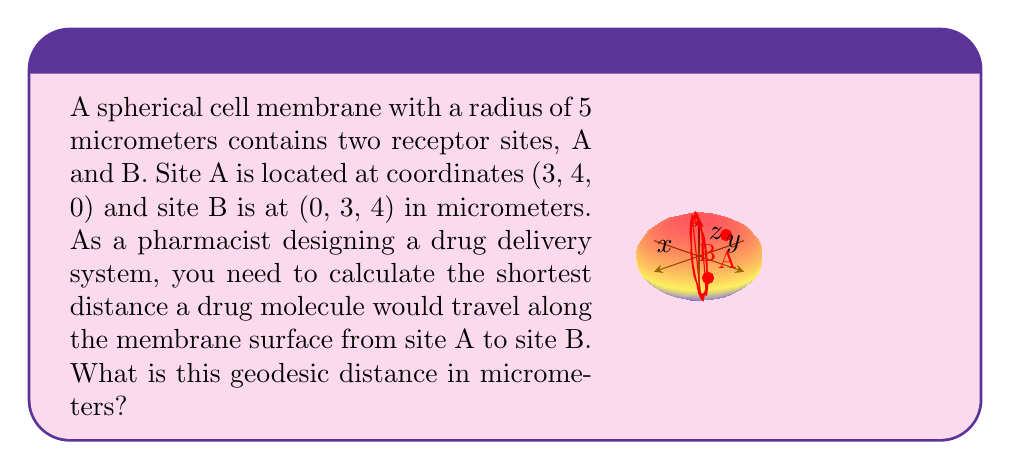Help me with this question. To solve this problem, we'll follow these steps:

1) First, recall that the geodesic distance between two points on a sphere is given by the arc length of the great circle passing through these points. The formula for this distance is:

   $$d = R \cdot \arccos\left(\frac{\mathbf{a} \cdot \mathbf{b}}{|\mathbf{a}||\mathbf{b}|}\right)$$

   where $R$ is the radius of the sphere, $\mathbf{a}$ and $\mathbf{b}$ are the position vectors of the two points, and $\cdot$ denotes the dot product.

2) We're given that $R = 5$ micrometers, $\mathbf{a} = (3, 4, 0)$, and $\mathbf{b} = (0, 3, 4)$.

3) Calculate the dot product $\mathbf{a} \cdot \mathbf{b}$:
   $$\mathbf{a} \cdot \mathbf{b} = 3(0) + 4(3) + 0(4) = 12$$

4) Calculate the magnitudes of $\mathbf{a}$ and $\mathbf{b}$:
   $$|\mathbf{a}| = \sqrt{3^2 + 4^2 + 0^2} = 5$$
   $$|\mathbf{b}| = \sqrt{0^2 + 3^2 + 4^2} = 5$$

5) Now we can plug these values into our formula:
   $$d = 5 \cdot \arccos\left(\frac{12}{5 \cdot 5}\right) = 5 \cdot \arccos\left(\frac{12}{25}\right)$$

6) Simplify:
   $$d = 5 \cdot \arccos(0.48) \approx 5 \cdot 1.0472 \approx 5.236$$

Therefore, the geodesic distance between the two receptor sites is approximately 5.236 micrometers.
Answer: $5.236$ micrometers 